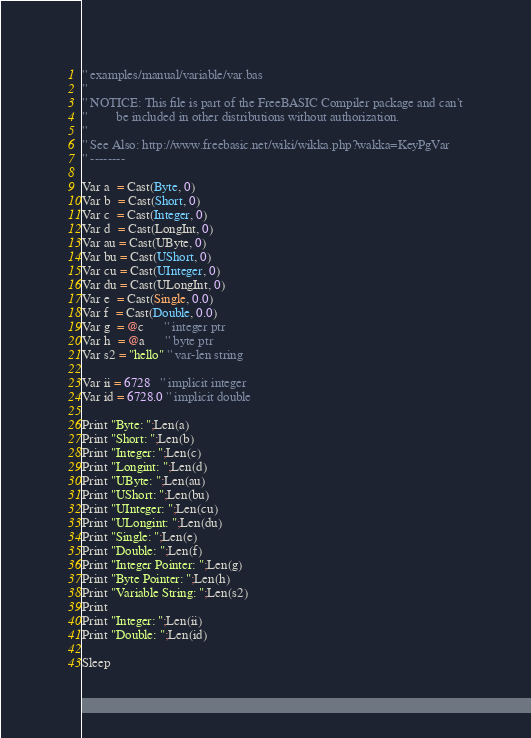Convert code to text. <code><loc_0><loc_0><loc_500><loc_500><_VisualBasic_>'' examples/manual/variable/var.bas
''
'' NOTICE: This file is part of the FreeBASIC Compiler package and can't
''         be included in other distributions without authorization.
''
'' See Also: http://www.freebasic.net/wiki/wikka.php?wakka=KeyPgVar
'' --------

Var a  = Cast(Byte, 0)
Var b  = Cast(Short, 0)
Var c  = Cast(Integer, 0)
Var d  = Cast(LongInt, 0)
Var au = Cast(UByte, 0)   
Var bu = Cast(UShort, 0)  
Var cu = Cast(UInteger, 0)
Var du = Cast(ULongInt, 0)
Var e  = Cast(Single, 0.0)
Var f  = Cast(Double, 0.0)
Var g  = @c      '' integer ptr
Var h  = @a      '' byte ptr
Var s2 = "hello" '' var-len string

Var ii = 6728   '' implicit integer
Var id = 6728.0 '' implicit double

Print "Byte: ";Len(a)
Print "Short: ";Len(b)
Print "Integer: ";Len(c)
Print "Longint: ";Len(d)
Print "UByte: ";Len(au)
Print "UShort: ";Len(bu)
Print "UInteger: ";Len(cu)
Print "ULongint: ";Len(du)
Print "Single: ";Len(e)
Print "Double: ";Len(f)
Print "Integer Pointer: ";Len(g)
Print "Byte Pointer: ";Len(h)
Print "Variable String: ";Len(s2)
Print
Print "Integer: ";Len(ii)
Print "Double: ";Len(id)

Sleep
</code> 